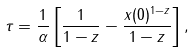<formula> <loc_0><loc_0><loc_500><loc_500>\tau = \frac { 1 } { \alpha } \left [ \frac { 1 } { 1 - z } - \frac { x ( 0 ) ^ { 1 - z } } { 1 - z } \right ] ,</formula> 